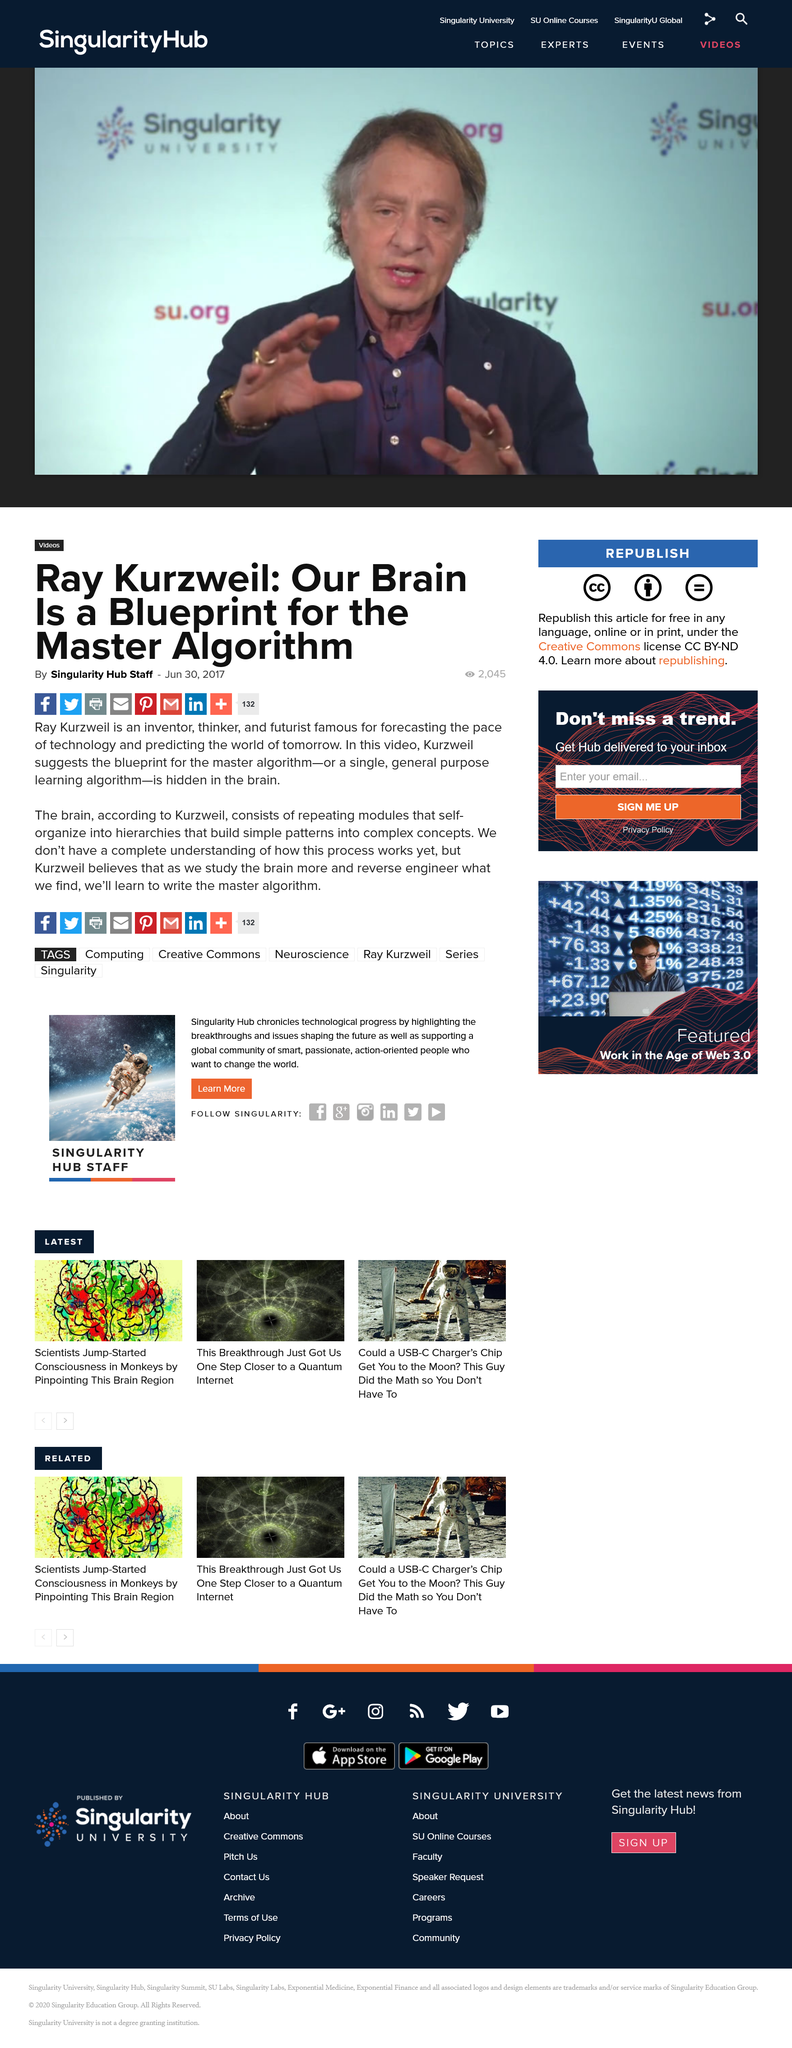Draw attention to some important aspects in this diagram. According to Kurzweil, by studying and reverse engineering the brain, we can expect to learn how to write the master algorithm, which will enable us to create even more advanced artificial intelligence. It is undeniable that we do not have a complete understanding of how the brain functions. Ray Kurzweil believes that the blueprint for the master algorithm is hidden in the human brain. 